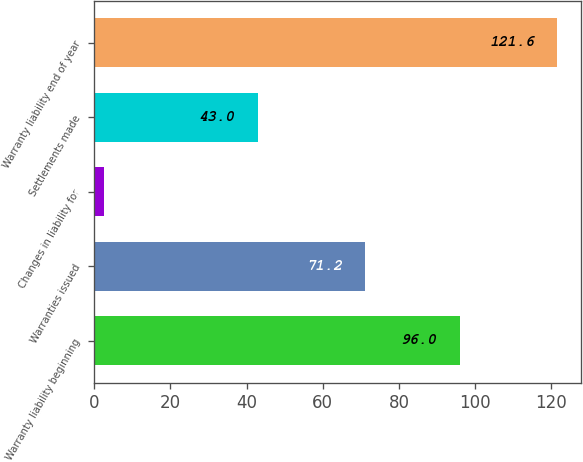Convert chart. <chart><loc_0><loc_0><loc_500><loc_500><bar_chart><fcel>Warranty liability beginning<fcel>Warranties issued<fcel>Changes in liability for<fcel>Settlements made<fcel>Warranty liability end of year<nl><fcel>96<fcel>71.2<fcel>2.6<fcel>43<fcel>121.6<nl></chart> 